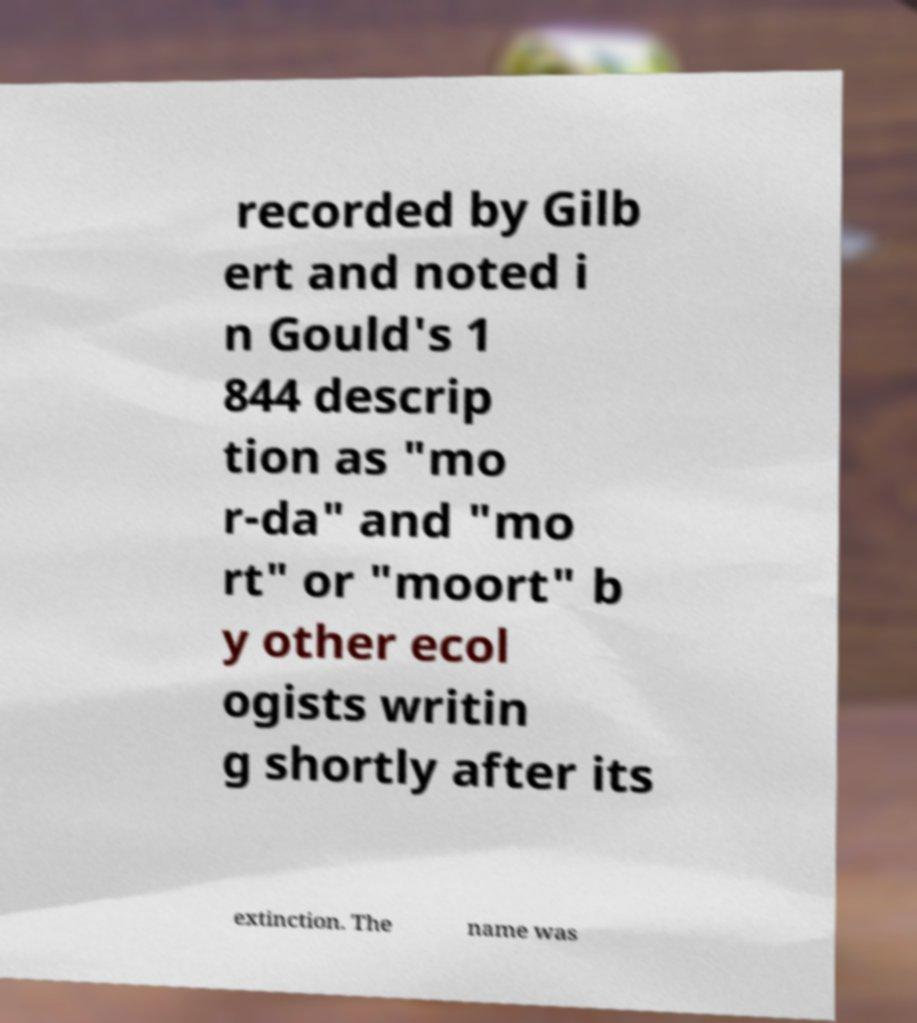Please identify and transcribe the text found in this image. recorded by Gilb ert and noted i n Gould's 1 844 descrip tion as "mo r-da" and "mo rt" or "moort" b y other ecol ogists writin g shortly after its extinction. The name was 